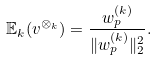<formula> <loc_0><loc_0><loc_500><loc_500>\mathbb { E } _ { k } ( v ^ { \otimes _ { k } } ) = \frac { w ^ { ( k ) } _ { p } } { \| w ^ { ( k ) } _ { p } \| ^ { 2 } _ { 2 } } .</formula> 